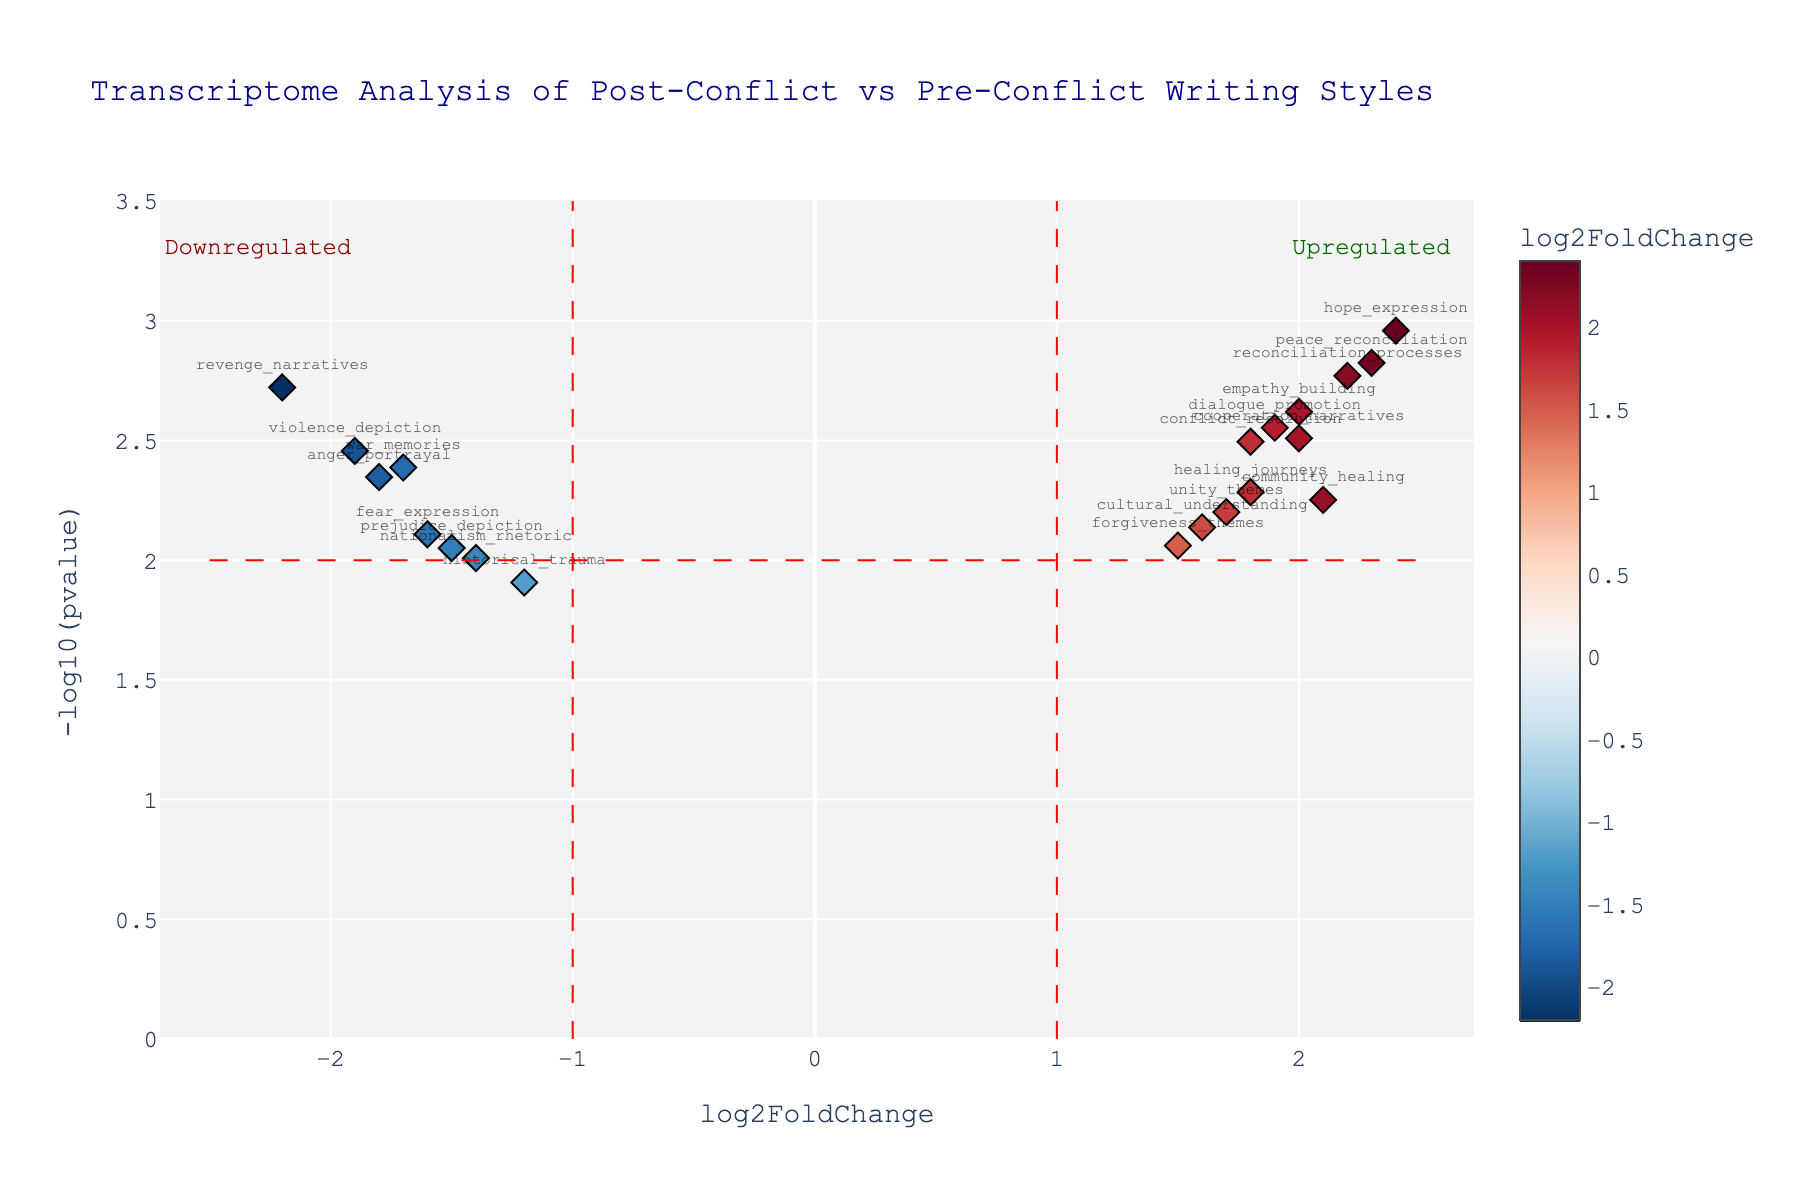What is the title of this plot? The title is located at the top of the plot. It describes what the plot is about, which in this case is "Transcriptome Analysis of Post-Conflict vs Pre-Conflict Writing Styles".
Answer: Transcriptome Analysis of Post-Conflict vs Pre-Conflict Writing Styles How many genes have a log2FoldChange greater than 2? By looking at the x-axis labels and locating points with an x-coordinate greater than 2, we can count these genes. There are two genes on the right side of the red dashed line at x=2.
Answer: 2 What is the gene with the highest -log10(pvalue) and what is its value? The highest -log10(pvalue) point will be the one furthest up on the y-axis. The gene "hope_expression" is at the top, and its -log10(pvalue) value can be noted fairly easily.
Answer: hope_expression, 3.96 (approximately) Which gene is more significantly downregulated, "revenge_narratives" or "war_memories"? To determine this, we compare the log2FoldChange values of these genes, looking for the one with a more negative value. "revenge_narratives" has a log2FoldChange of -2.2 while "war_memories" has -1.7.
Answer: revenge_narratives How many genes have a pvalue less than 0.005? To find this, we need to identify which genes have a -log10(pvalue) greater than -log10(0.005), which is approximately 2.3. These points are above the red horizontal line at y=2.3. There are six such genes.
Answer: 6 What is the log2FoldChange for "dialogue_promotion" and how significant is it? We locate "dialogue_promotion" on the plot and read its log2FoldChange which is approximately 1.9. The significance is indicated by its pvalue, which converts to a -log10(pvalue) above 2.3.
Answer: 1.9, highly significant How are the genes with significant expression changes divided in terms of upregulation and downregulation? Significant expression changes are indicated by points outside the -1 and 1 log2FoldChange boundaries, and above the horizontal cutoff at y=2. We count the number of points on each side. There are 8 upregulated and 5 downregulated genes.
Answer: 8 upregulated, 5 downregulated Which gene located around a log2FoldChange of 2 has the lowest pvalue? We look at the cluster of points around x=2 and determine which one is highest on the y-axis. "peace_reconciliation" is closest to x=2 with the highest -log10(pvalue).
Answer: peace_reconciliation, approximately 3.82 